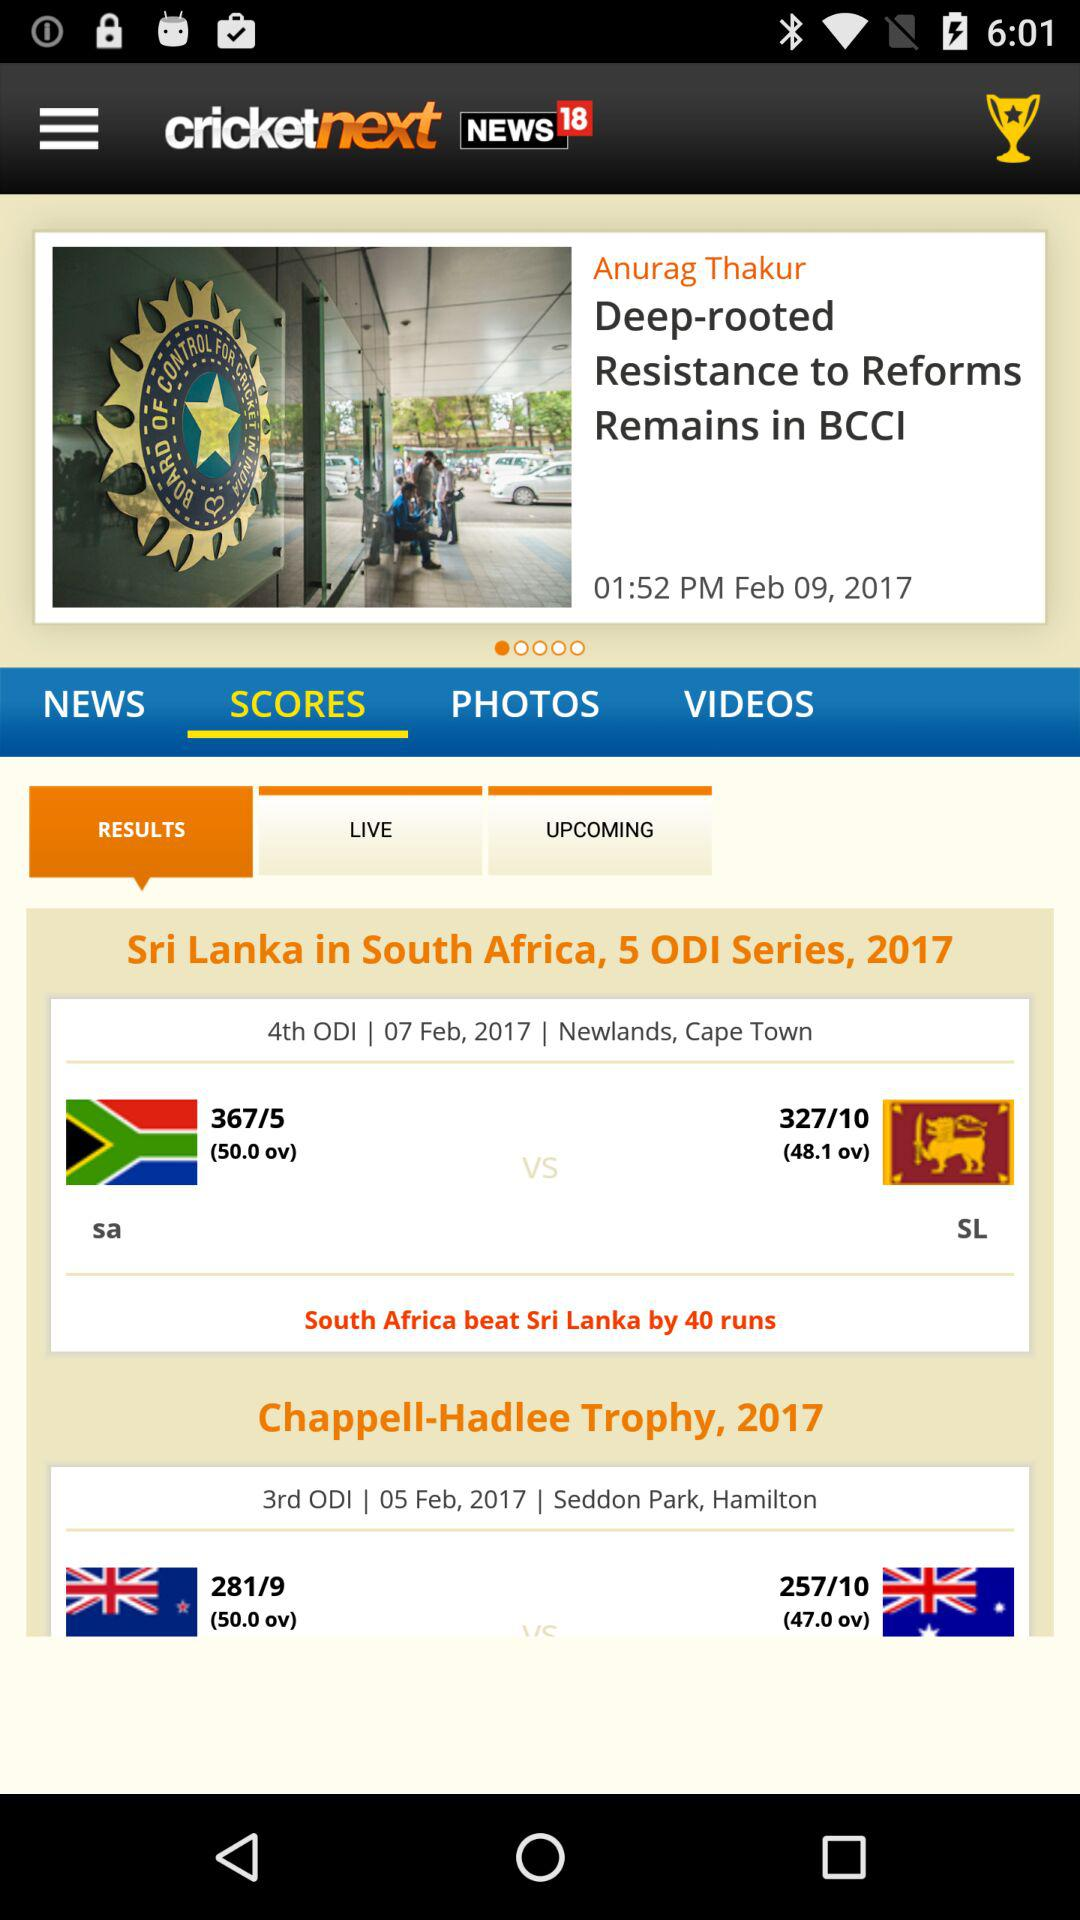By how many runs did "South Africa" beat "Sri Lanka"? "South Africa" beat "Sri Lanka" by 40 runs. 